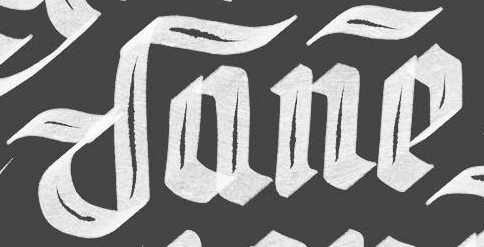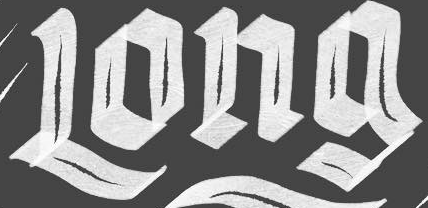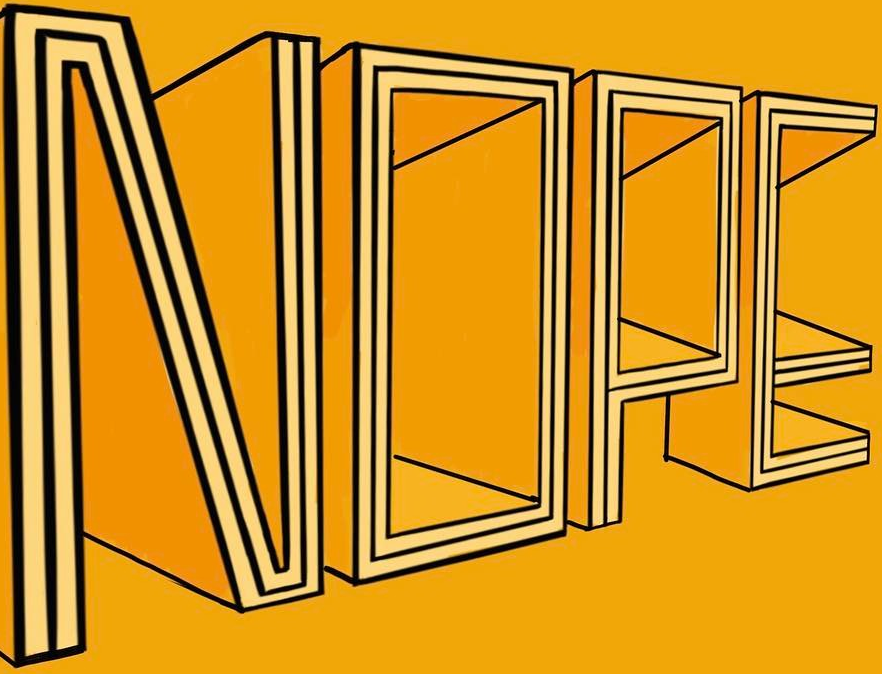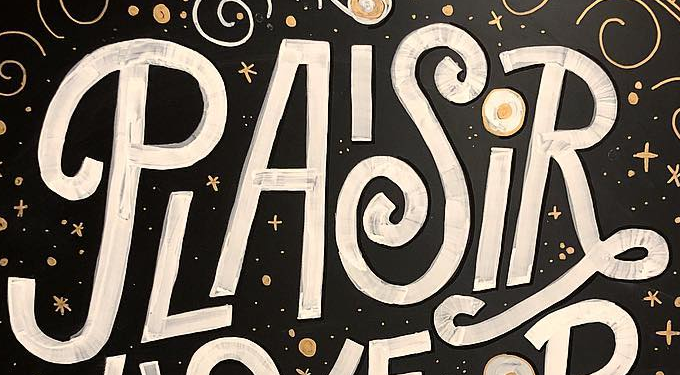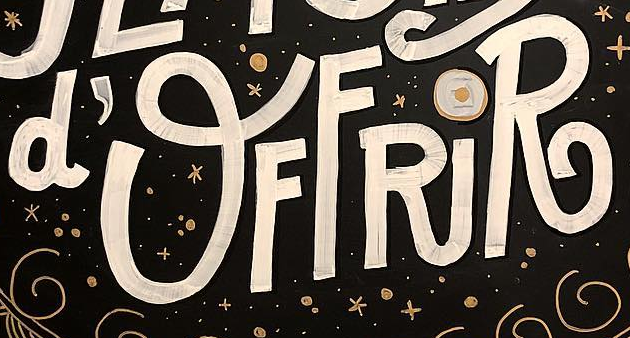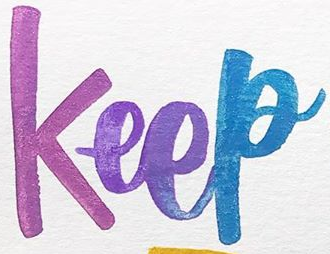Identify the words shown in these images in order, separated by a semicolon. Dane; Long; NOPE; PLAISiR; d'OFFRiR; Keep 